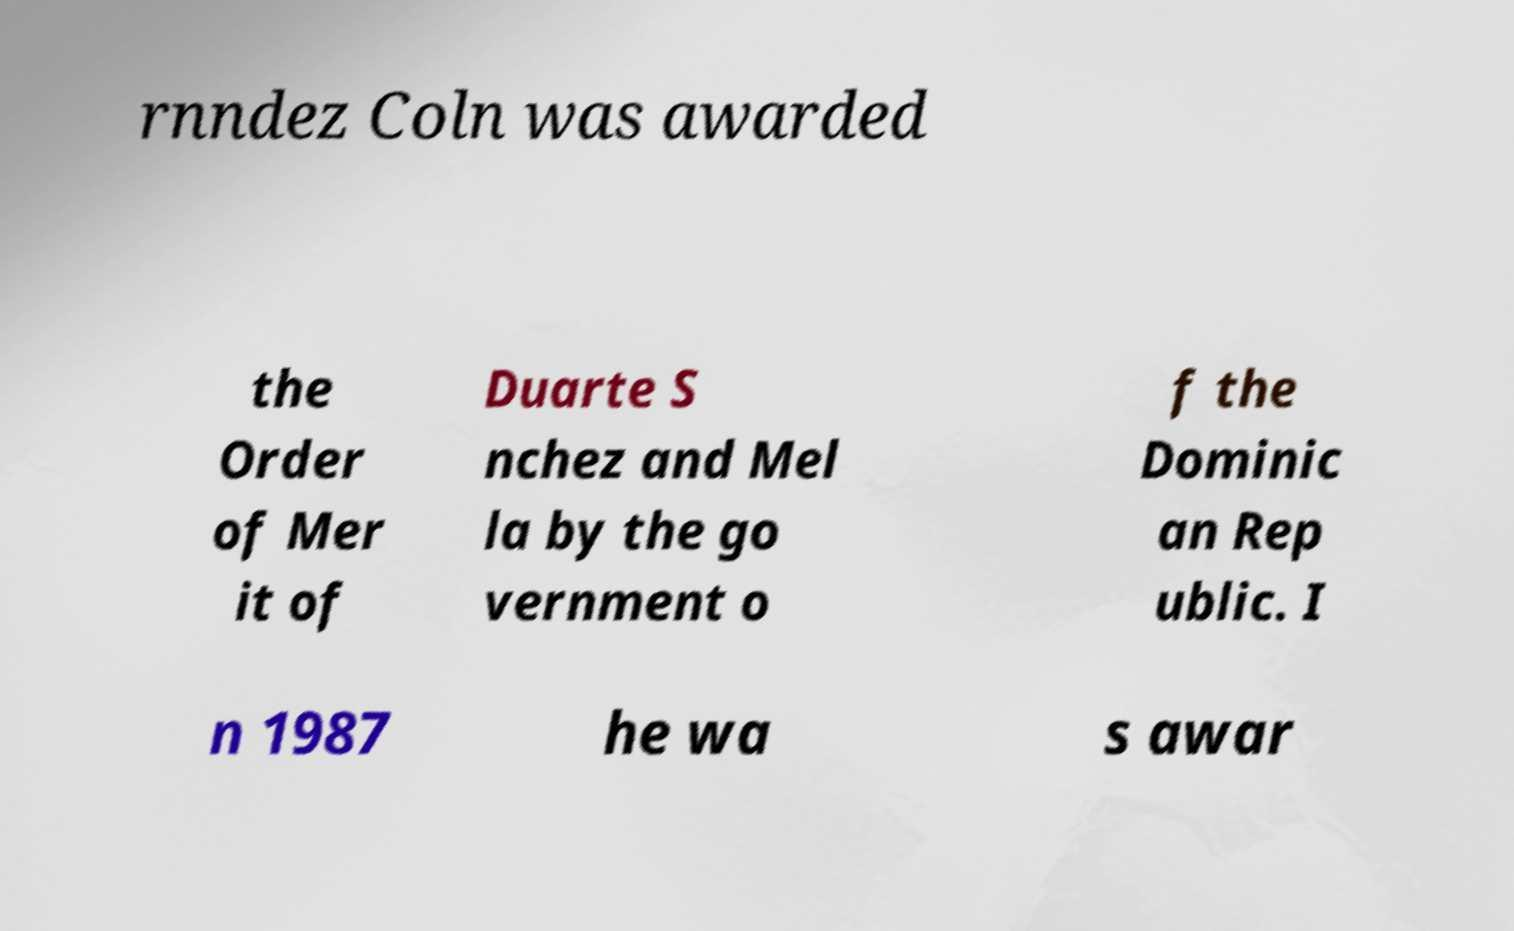Can you read and provide the text displayed in the image?This photo seems to have some interesting text. Can you extract and type it out for me? rnndez Coln was awarded the Order of Mer it of Duarte S nchez and Mel la by the go vernment o f the Dominic an Rep ublic. I n 1987 he wa s awar 